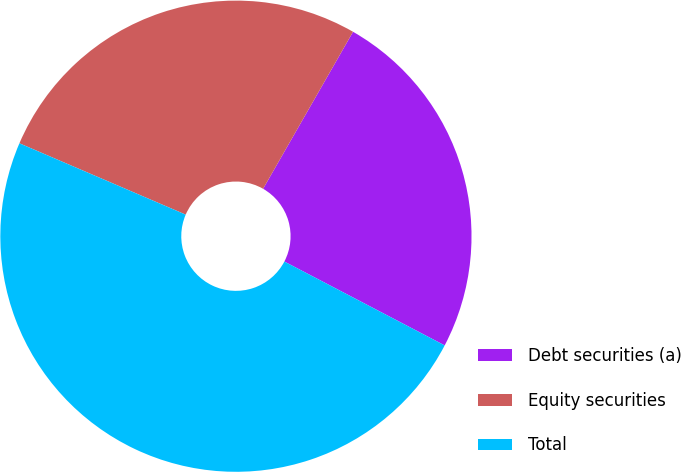Convert chart. <chart><loc_0><loc_0><loc_500><loc_500><pie_chart><fcel>Debt securities (a)<fcel>Equity securities<fcel>Total<nl><fcel>24.39%<fcel>26.83%<fcel>48.78%<nl></chart> 